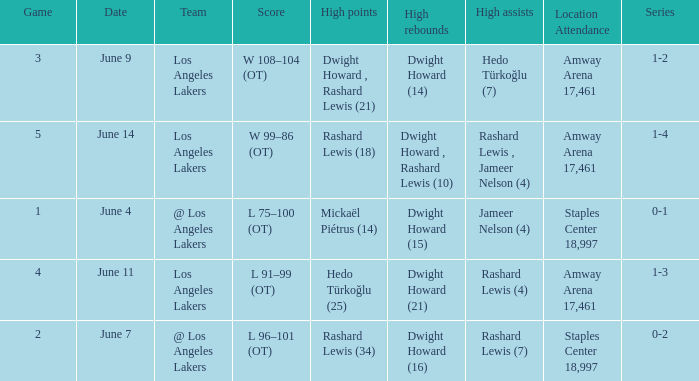What is High Assists, when High Rebounds is "Dwight Howard , Rashard Lewis (10)"? Rashard Lewis , Jameer Nelson (4). 